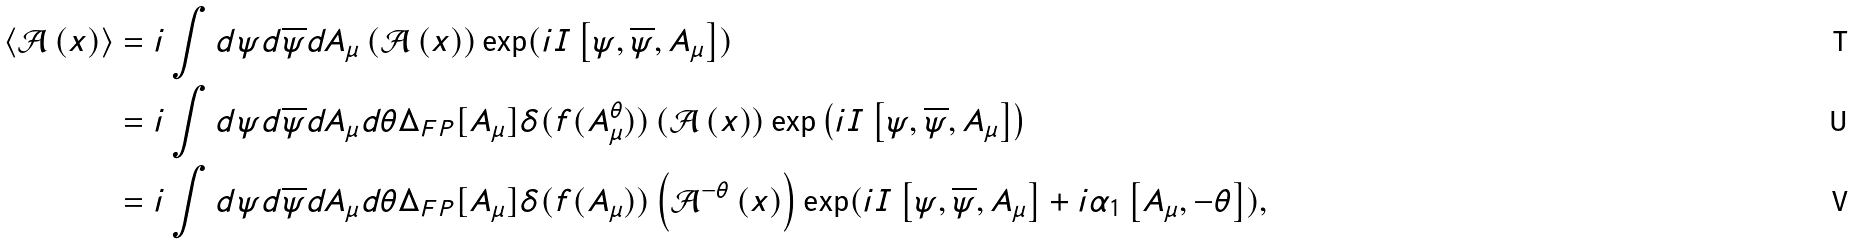<formula> <loc_0><loc_0><loc_500><loc_500>\left \langle \mathcal { A } \left ( x \right ) \right \rangle & = i \int d \psi d \overline { \psi } d A _ { \mu } \left ( { \mathcal { A } } \left ( x \right ) \right ) \exp ( i I \left [ \psi , \overline { \psi } , A _ { \mu } \right ] ) \\ & = i \int d \psi d \overline { \psi } d A _ { \mu } d \theta { \Delta } _ { F P } [ A _ { \mu } ] \delta ( f ( A _ { \mu } ^ { \theta } ) ) \left ( { \mathcal { A } } \left ( x \right ) \right ) \exp \left ( i I \left [ \psi , \overline { \psi } , A _ { \mu } \right ] \right ) \\ & = i \int d \psi d \overline { \psi } d A _ { \mu } d \theta { \Delta } _ { F P } [ A _ { \mu } ] \delta ( f ( A _ { \mu } ) ) \left ( { \mathcal { A } } ^ { - \theta } \left ( x \right ) \right ) \exp ( i I \left [ \psi , \overline { \psi } , A _ { \mu } \right ] + i \alpha _ { 1 } \left [ A _ { \mu } , - \theta \right ] ) ,</formula> 